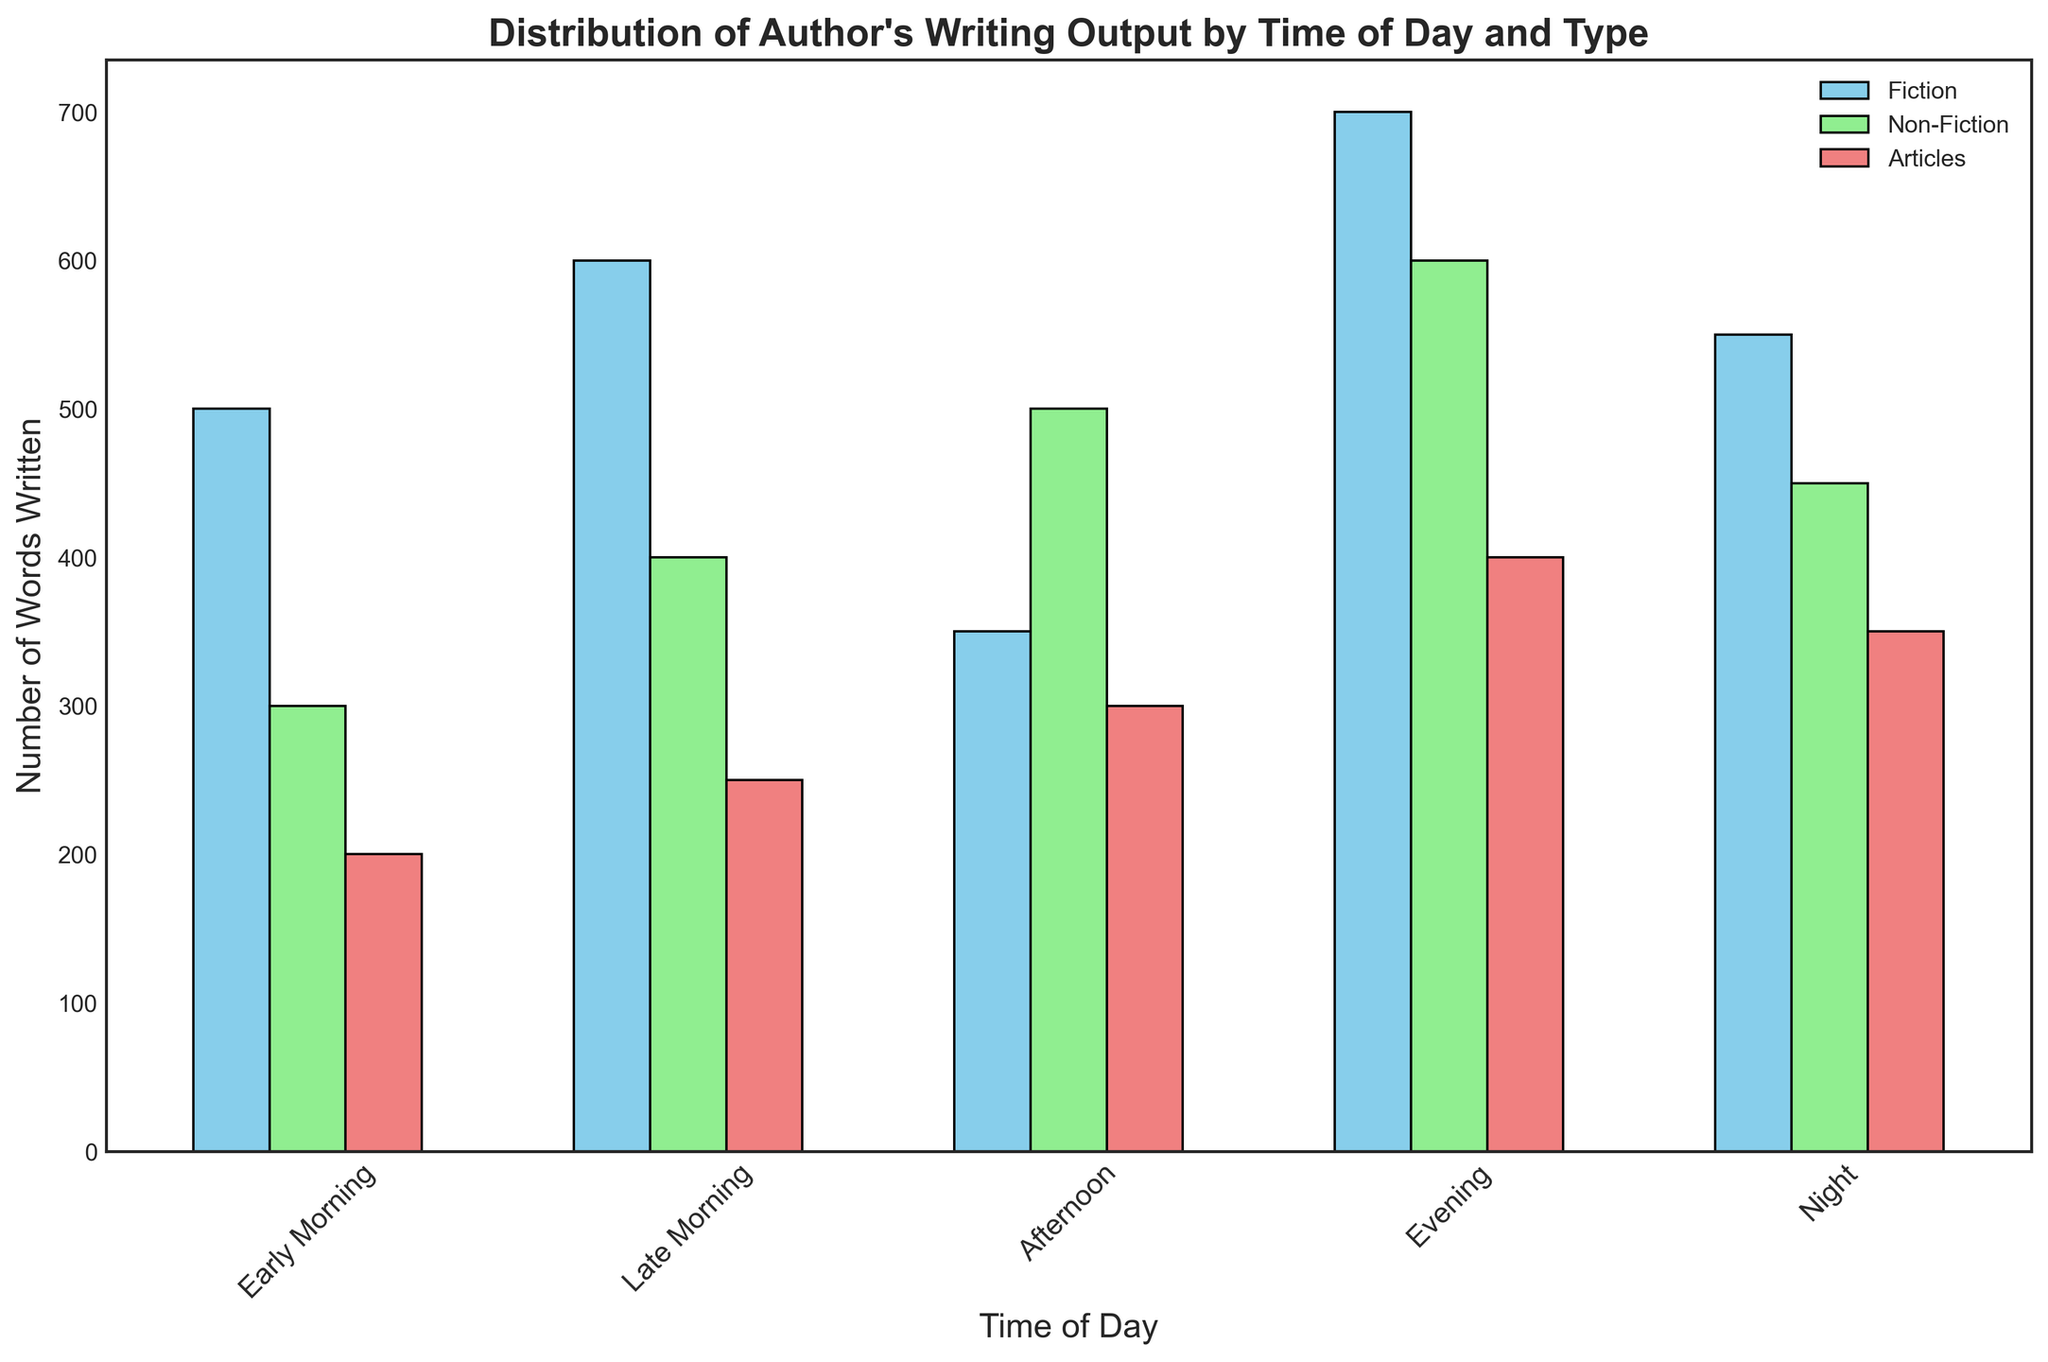Which time of day sees the highest overall writing output? To find the time of day with the highest overall writing output, sum the number of words written in Fiction, Non-Fiction, and Articles for each time period. Compare these sums for all time periods.
Answer: Evening How many more words does the author write in Fiction during the evening compared to the afternoon? To determine the difference in words written in Fiction between the evening and the afternoon, subtract the Fiction words for the afternoon from the Fiction words for the evening: 700 - 350.
Answer: 350 What is the average number of words written in Non-Fiction across all time periods? To find the average, sum the Non-Fiction words written in each time period and divide by the number of time periods: (300 + 400 + 500 + 600 + 450)/5.
Answer: 450 During which time of day is the proportion of Fiction writing the highest compared to the total writing output for that time period? Calculate the proportion of Fiction writing by dividing the Fiction words by the total words (sum of Fiction, Non-Fiction, and Articles) for each time period. Compare these proportions to determine the highest.
Answer: Evening How does the author's Article output during 'Late Morning' compare to 'Night'? Compare the number of words written in Articles during 'Late Morning' (250) to 'Night' (350). 'Night' has the higher value.
Answer: Night Which category has the most significant increase in output from 'Afternoon' to 'Evening'? Calculate the increase in words written for each category (Fiction, Non-Fiction, Articles) from 'Afternoon' to 'Evening'. Compare these increases to determine the most significant one.
Answer: Articles What is the total number of words written during 'Early Morning'? Sum the number of words written in Fiction, Non-Fiction, and Articles during 'Early Morning': 500 + 300 + 200.
Answer: 1000 By how many words does the author's writing output in Non-Fiction during the 'Afternoon' exceed their Fiction output during 'Afternoon'? Subtract the Fiction words during the 'Afternoon' from the Non-Fiction words during the 'Afternoon': 500 - 350.
Answer: 150 Which content type has the smallest variability in terms of word counts across different time periods? Assess the range (max-min) of word counts for Fiction, Non-Fiction, and Articles across different time periods. The type with the smallest range has the smallest variability.
Answer: Articles What color represents the 'Non-Fiction' category in the plot? Identify the color used for the bars representing the 'Non-Fiction' category in the plot.
Answer: Light green 